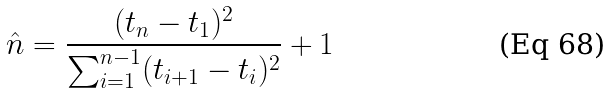<formula> <loc_0><loc_0><loc_500><loc_500>\hat { n } = \frac { ( t _ { n } - t _ { 1 } ) ^ { 2 } } { \sum _ { i = 1 } ^ { n - 1 } ( t _ { i + 1 } - t _ { i } ) ^ { 2 } } + 1</formula> 